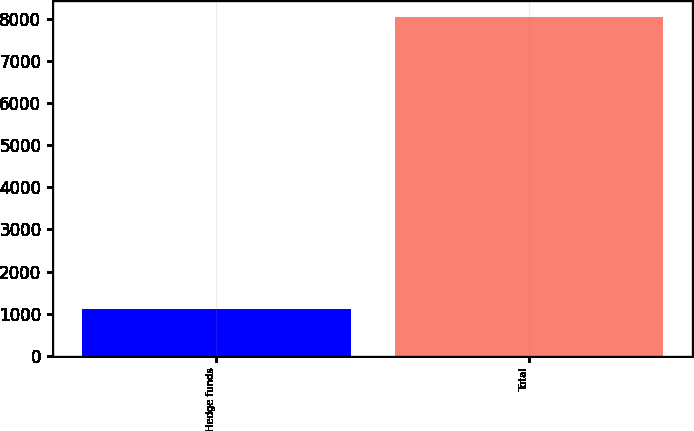<chart> <loc_0><loc_0><loc_500><loc_500><bar_chart><fcel>Hedge funds<fcel>Total<nl><fcel>1109<fcel>8026<nl></chart> 